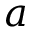Convert formula to latex. <formula><loc_0><loc_0><loc_500><loc_500>a</formula> 